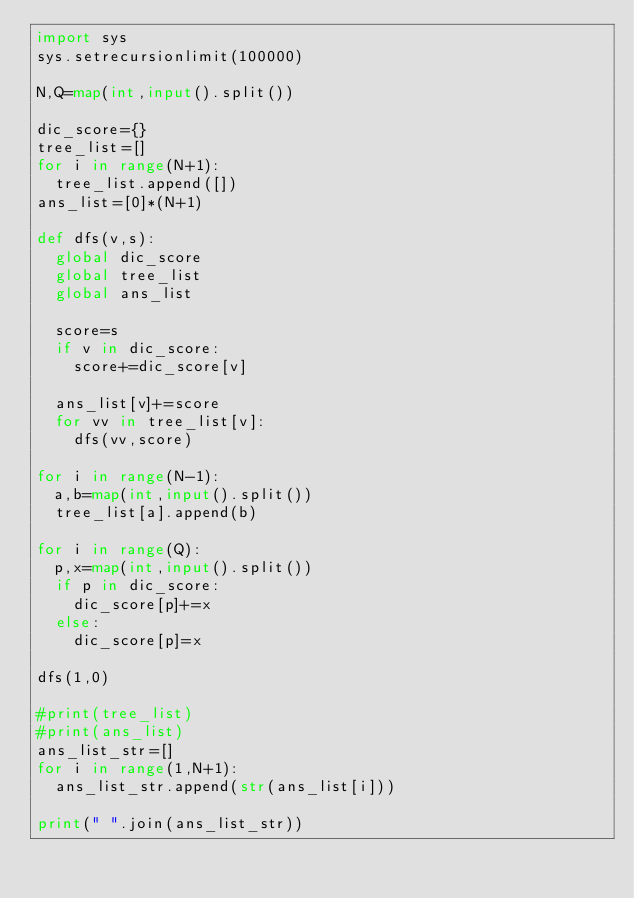Convert code to text. <code><loc_0><loc_0><loc_500><loc_500><_Python_>import sys
sys.setrecursionlimit(100000)

N,Q=map(int,input().split())

dic_score={}
tree_list=[]
for i in range(N+1):
  tree_list.append([])
ans_list=[0]*(N+1)

def dfs(v,s):
  global dic_score
  global tree_list
  global ans_list
  
  score=s
  if v in dic_score:
    score+=dic_score[v]
    
  ans_list[v]+=score
  for vv in tree_list[v]:
    dfs(vv,score)

for i in range(N-1):
  a,b=map(int,input().split())
  tree_list[a].append(b)
  
for i in range(Q):
  p,x=map(int,input().split())
  if p in dic_score:
    dic_score[p]+=x
  else:
    dic_score[p]=x

dfs(1,0)

#print(tree_list)
#print(ans_list)
ans_list_str=[]
for i in range(1,N+1):
  ans_list_str.append(str(ans_list[i]))

print(" ".join(ans_list_str))</code> 